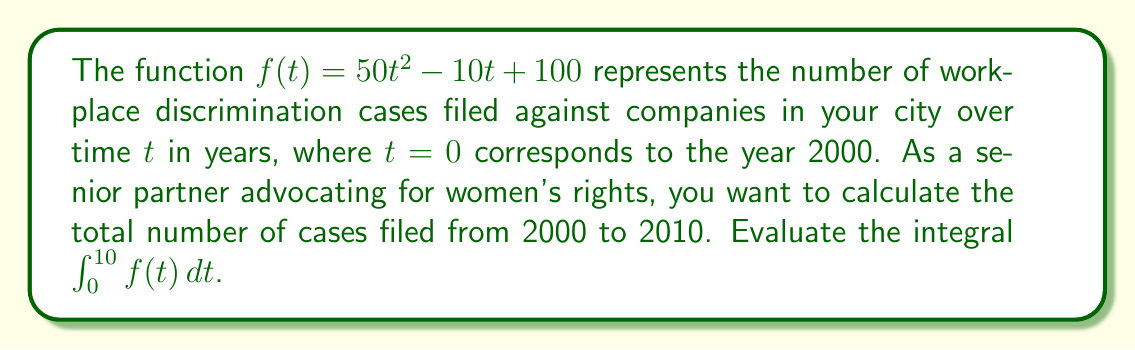Can you solve this math problem? To solve this problem, we need to integrate the function $f(t) = 50t^2 - 10t + 100$ from $t=0$ to $t=10$. Let's break it down step-by-step:

1) First, let's set up the definite integral:
   $$\int_0^{10} (50t^2 - 10t + 100) dt$$

2) Now, we integrate each term:
   $$\left[\frac{50t^3}{3} - \frac{10t^2}{2} + 100t\right]_0^{10}$$

3) Let's evaluate this at the upper and lower bounds:
   At $t=10$: $\frac{50(10^3)}{3} - \frac{10(10^2)}{2} + 100(10)$
   At $t=0$: $\frac{50(0^3)}{3} - \frac{10(0^2)}{2} + 100(0) = 0$

4) Simplify the upper bound:
   $\frac{50000}{3} - 500 + 1000 = 16666.67 - 500 + 1000 = 17166.67$

5) Subtract the lower bound (which is 0):
   $17166.67 - 0 = 17166.67$

Therefore, the total number of discrimination cases filed from 2000 to 2010 is approximately 17,167.
Answer: 17,167 cases 